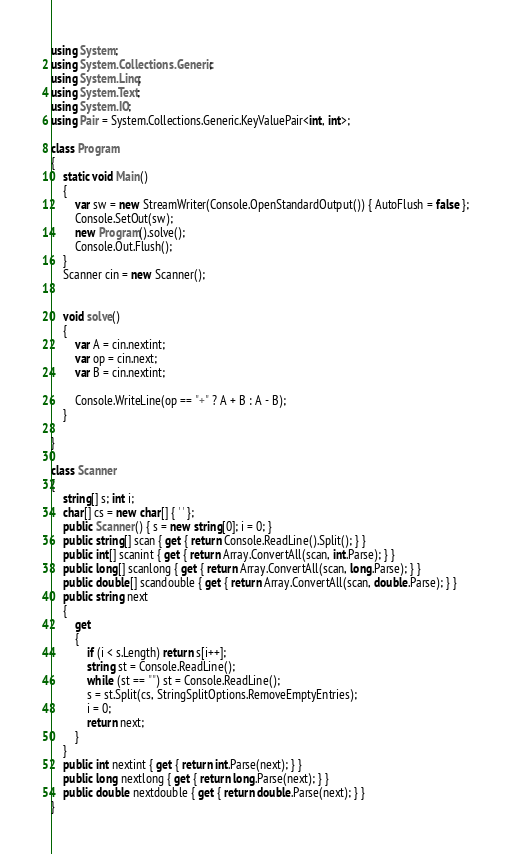Convert code to text. <code><loc_0><loc_0><loc_500><loc_500><_C#_>using System;
using System.Collections.Generic;
using System.Linq;
using System.Text;
using System.IO;
using Pair = System.Collections.Generic.KeyValuePair<int, int>;

class Program
{
    static void Main()
    {
        var sw = new StreamWriter(Console.OpenStandardOutput()) { AutoFlush = false };
        Console.SetOut(sw);
        new Program().solve();
        Console.Out.Flush();
    }
    Scanner cin = new Scanner();


    void solve()
    {
        var A = cin.nextint;
        var op = cin.next;
        var B = cin.nextint;

        Console.WriteLine(op == "+" ? A + B : A - B);
    }

}

class Scanner
{
    string[] s; int i;
    char[] cs = new char[] { ' ' };
    public Scanner() { s = new string[0]; i = 0; }
    public string[] scan { get { return Console.ReadLine().Split(); } }
    public int[] scanint { get { return Array.ConvertAll(scan, int.Parse); } }
    public long[] scanlong { get { return Array.ConvertAll(scan, long.Parse); } }
    public double[] scandouble { get { return Array.ConvertAll(scan, double.Parse); } }
    public string next
    {
        get
        {
            if (i < s.Length) return s[i++];
            string st = Console.ReadLine();
            while (st == "") st = Console.ReadLine();
            s = st.Split(cs, StringSplitOptions.RemoveEmptyEntries);
            i = 0;
            return next;
        }
    }
    public int nextint { get { return int.Parse(next); } }
    public long nextlong { get { return long.Parse(next); } }
    public double nextdouble { get { return double.Parse(next); } }
}
</code> 